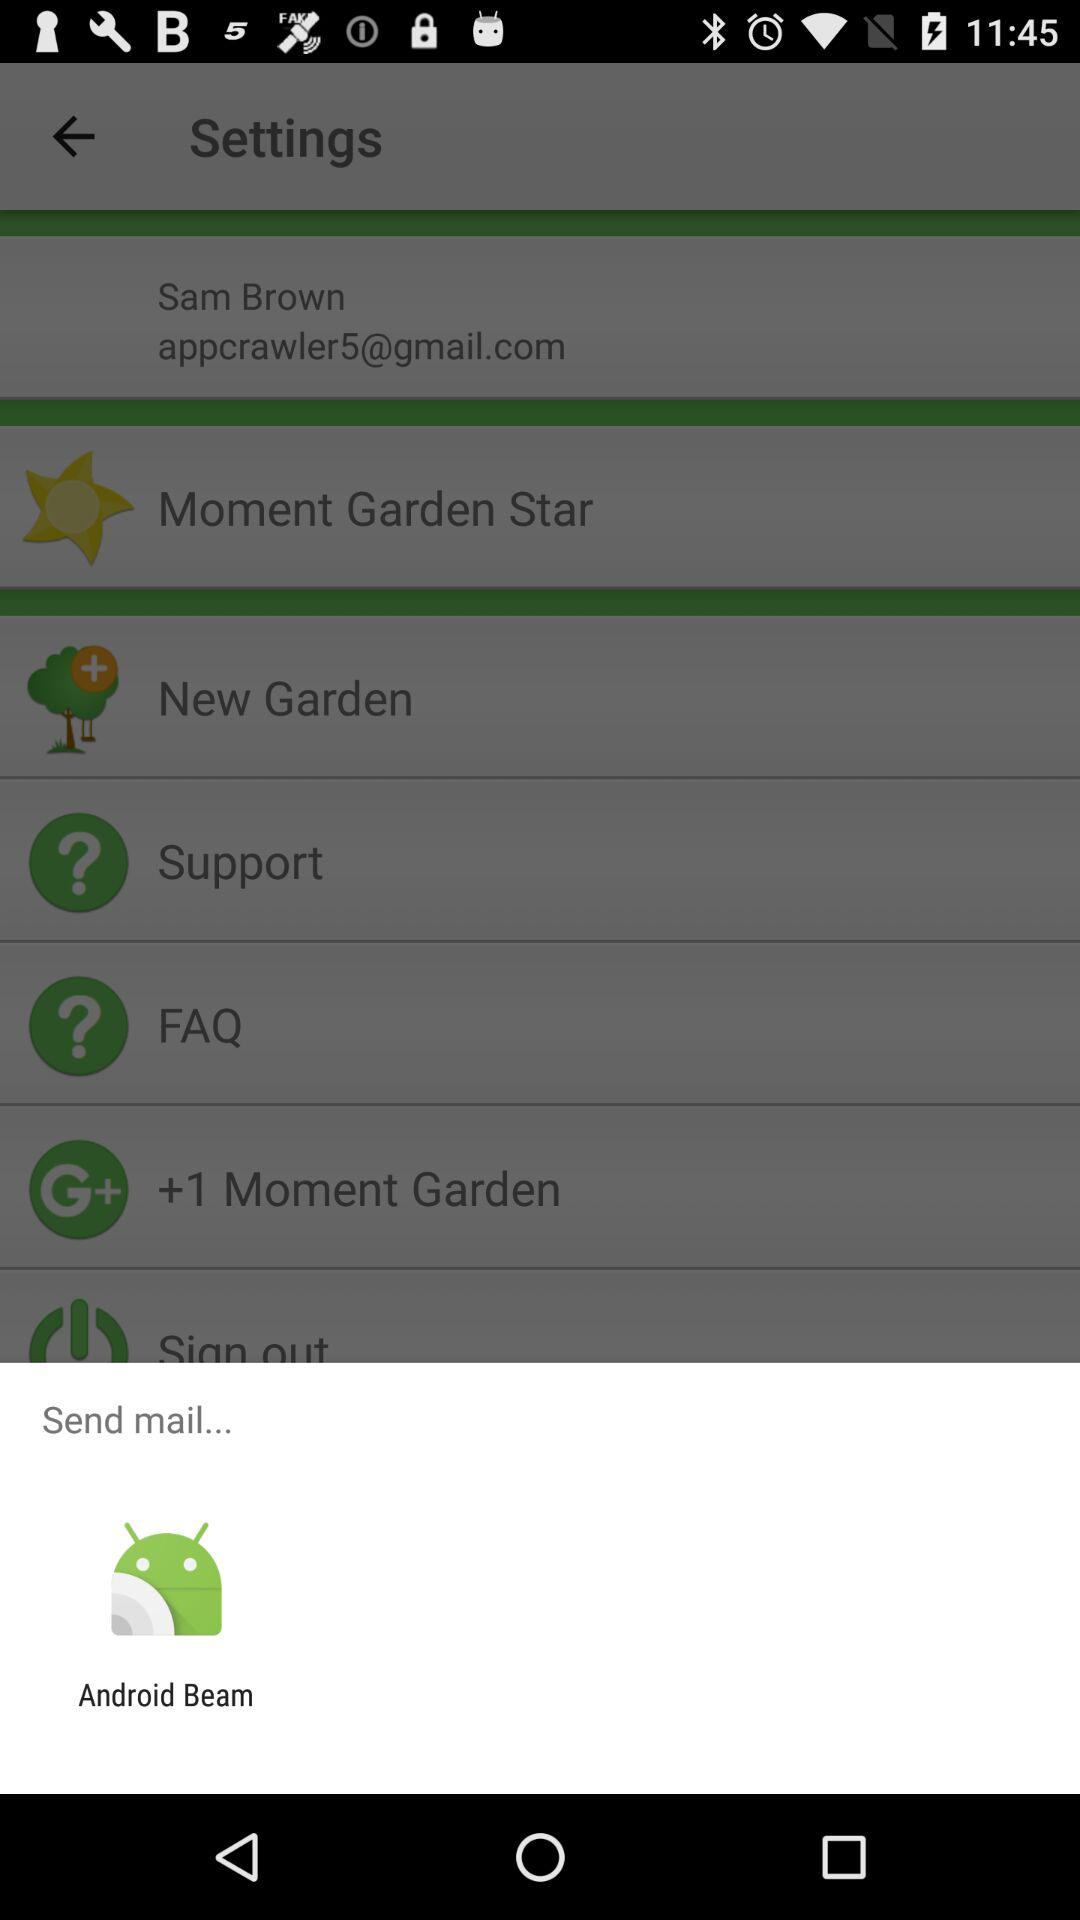What application is given for sending email? The application given for sending email is "Android Beam". 